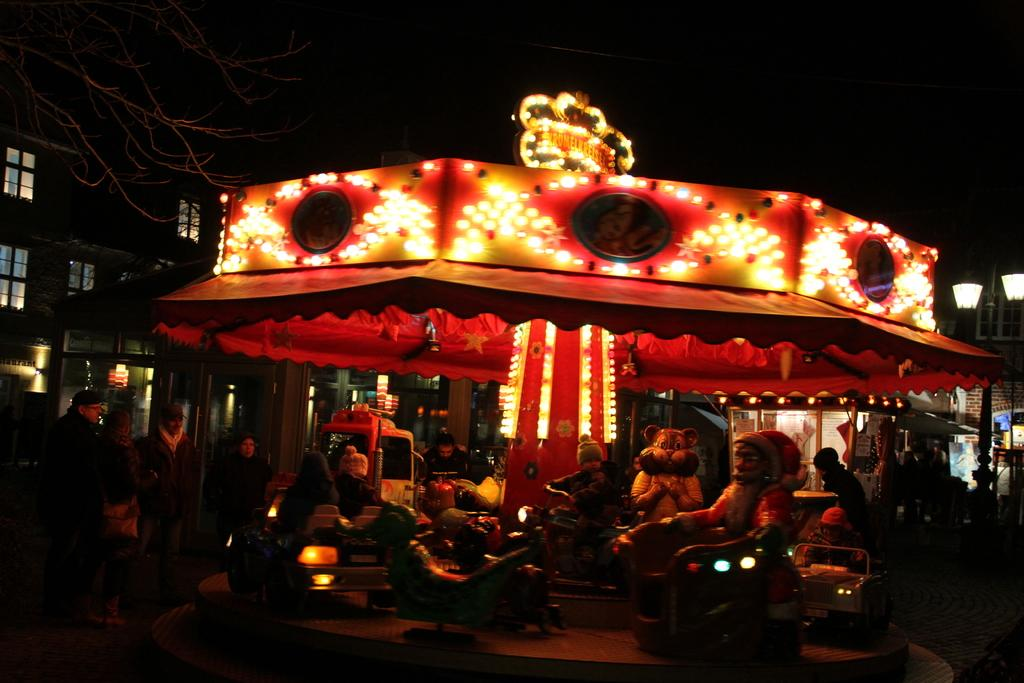What is the main subject in the center of the image? There is a fun ride in the center of the image. What can be seen in the background of the image? There is a building, persons, lights, and the sky visible in the background of the image. How many stitches are visible on the twig in the image? There is no twig present in the image, so it is not possible to determine the number of stitches on it. 